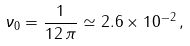<formula> <loc_0><loc_0><loc_500><loc_500>\nu _ { 0 } = \frac { 1 } { 1 2 \, \pi } \simeq 2 . 6 \times 1 0 ^ { - 2 } \, ,</formula> 